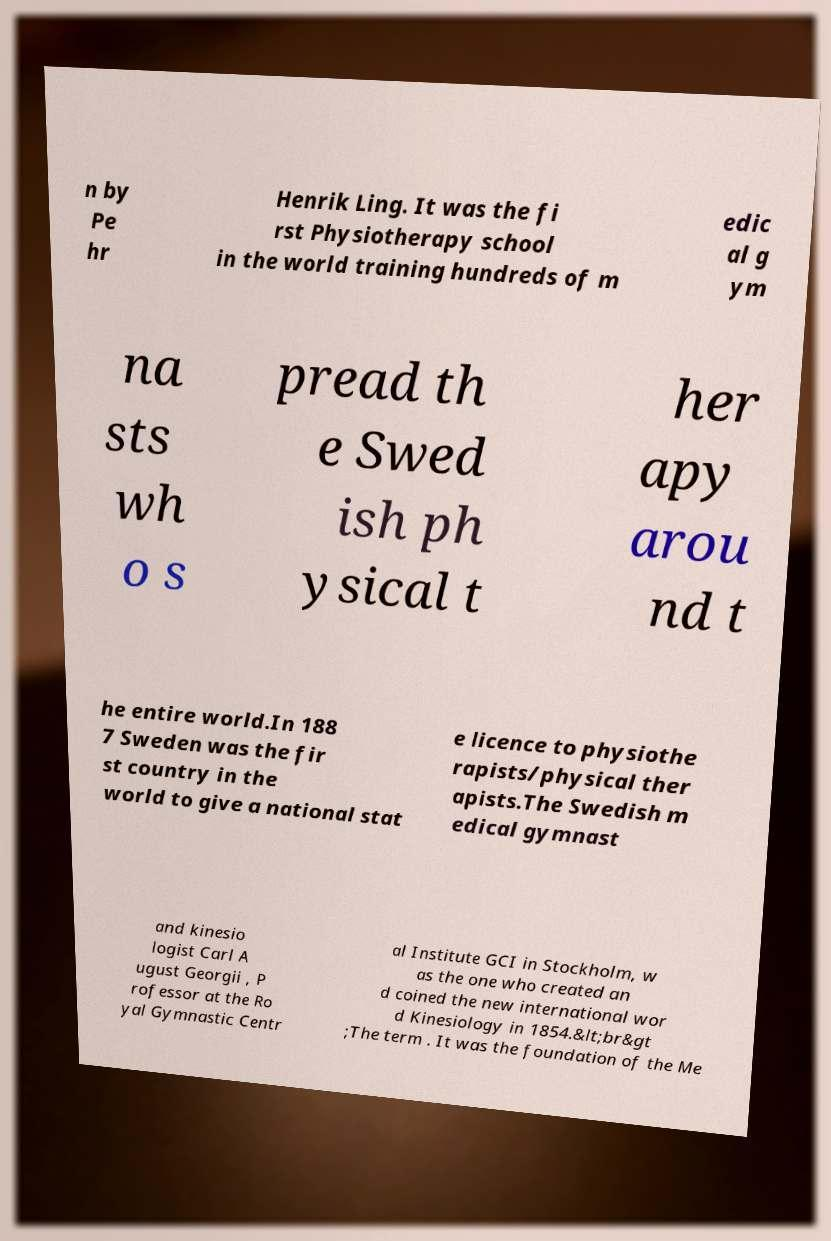Could you extract and type out the text from this image? n by Pe hr Henrik Ling. It was the fi rst Physiotherapy school in the world training hundreds of m edic al g ym na sts wh o s pread th e Swed ish ph ysical t her apy arou nd t he entire world.In 188 7 Sweden was the fir st country in the world to give a national stat e licence to physiothe rapists/physical ther apists.The Swedish m edical gymnast and kinesio logist Carl A ugust Georgii , P rofessor at the Ro yal Gymnastic Centr al Institute GCI in Stockholm, w as the one who created an d coined the new international wor d Kinesiology in 1854.&lt;br&gt ;The term . It was the foundation of the Me 